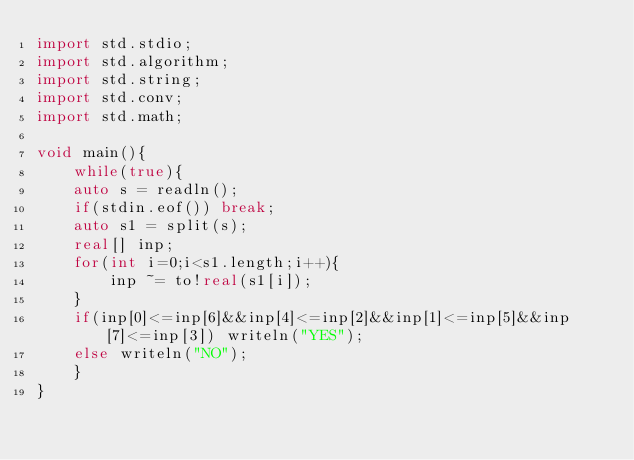<code> <loc_0><loc_0><loc_500><loc_500><_D_>import std.stdio;
import std.algorithm;
import std.string;
import std.conv;
import std.math;

void main(){
    while(true){
	auto s = readln();
	if(stdin.eof()) break;
	auto s1 = split(s);
	real[] inp;
	for(int i=0;i<s1.length;i++){
	    inp ~= to!real(s1[i]);
	}
	if(inp[0]<=inp[6]&&inp[4]<=inp[2]&&inp[1]<=inp[5]&&inp[7]<=inp[3]) writeln("YES");
	else writeln("NO");
    }
}</code> 